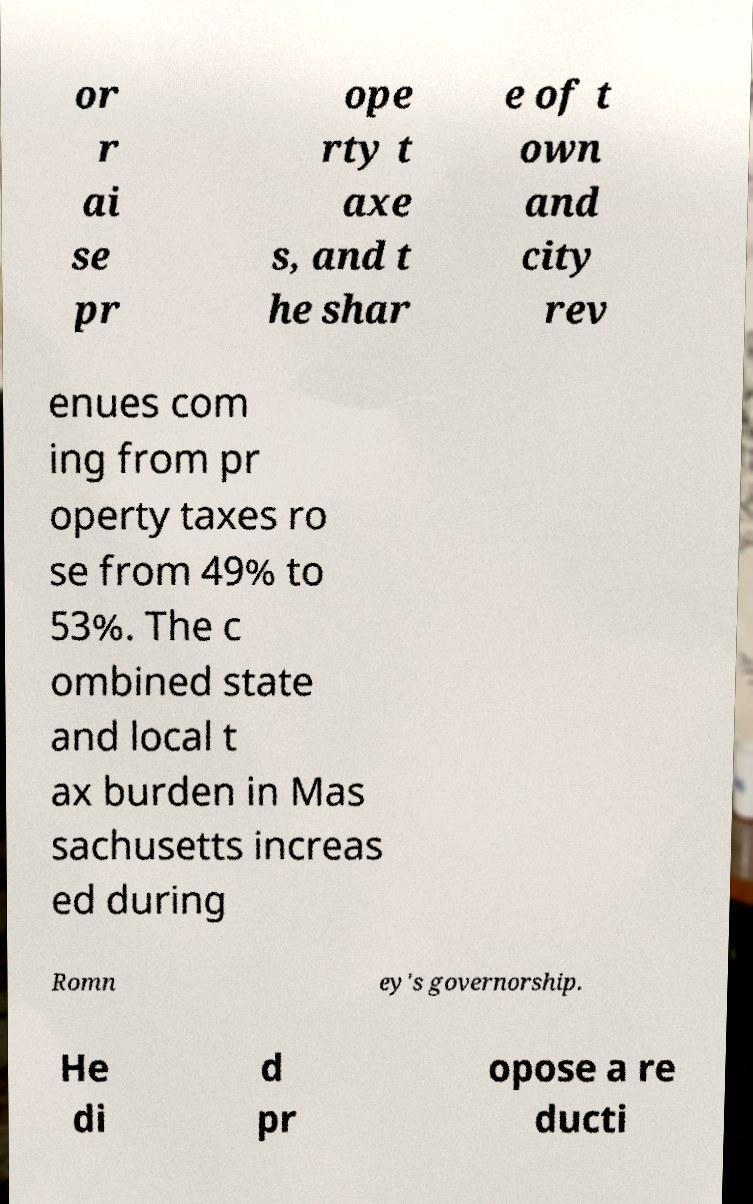There's text embedded in this image that I need extracted. Can you transcribe it verbatim? or r ai se pr ope rty t axe s, and t he shar e of t own and city rev enues com ing from pr operty taxes ro se from 49% to 53%. The c ombined state and local t ax burden in Mas sachusetts increas ed during Romn ey's governorship. He di d pr opose a re ducti 